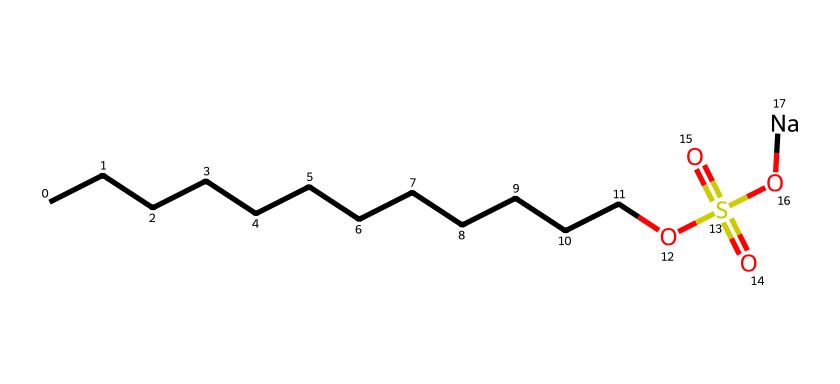What is the total number of carbon atoms in sodium lauryl sulfate? To find the total number of carbon atoms, count the number of 'C' characters in the SMILES representation. In this case, there are 12 carbon atoms represented by the continuous chain of 'C's.
Answer: 12 How many oxygen atoms are present in sodium lauryl sulfate? In the SMILES representation, the 'O' (oxygen) atoms are directly counted. There are 4 oxygen atoms visible in the structure (one from the sulfate group and three from the -SO4 part).
Answer: 4 What functional group is present in sodium lauryl sulfate? The structure contains a sulfate group (indicated by the -OS(=O)(=O)O part), which is a distinct functional group recognized in organic chemistry as a sulfate.
Answer: sulfate Is sodium lauryl sulfate considered a hazardous chemical? Sodium lauryl sulfate can cause skin irritation and other adverse effects in some individuals, which qualifies it as a hazardous substance in certain contexts.
Answer: yes What type of surfactant is sodium lauryl sulfate classified as? Based on its structure, sodium lauryl sulfate can be classified as an anionic surfactant due to the negatively charged sulfate group and is commonly used in cleaning products.
Answer: anionic Which part of sodium lauryl sulfate makes it hydrophilic? The sulfate ion (represented by the -OS(=O)(=O)O part) is polar and soluble in water, contributing to the hydrophilic character of this molecule.
Answer: sulfate ion How does the long carbon chain of sodium lauryl sulfate influence its properties? The long carbon chain (the 'CCCCCCCCCCCC' part) is hydrophobic, which helps the compound interact with oils and fats, adding to its effectiveness as a surfactant.
Answer: hydrophobic carbon chain 